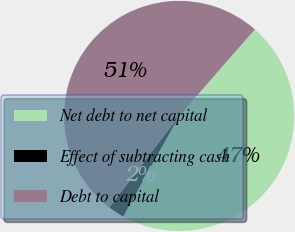Convert chart. <chart><loc_0><loc_0><loc_500><loc_500><pie_chart><fcel>Net debt to net capital<fcel>Effect of subtracting cash<fcel>Debt to capital<nl><fcel>46.64%<fcel>2.28%<fcel>51.08%<nl></chart> 